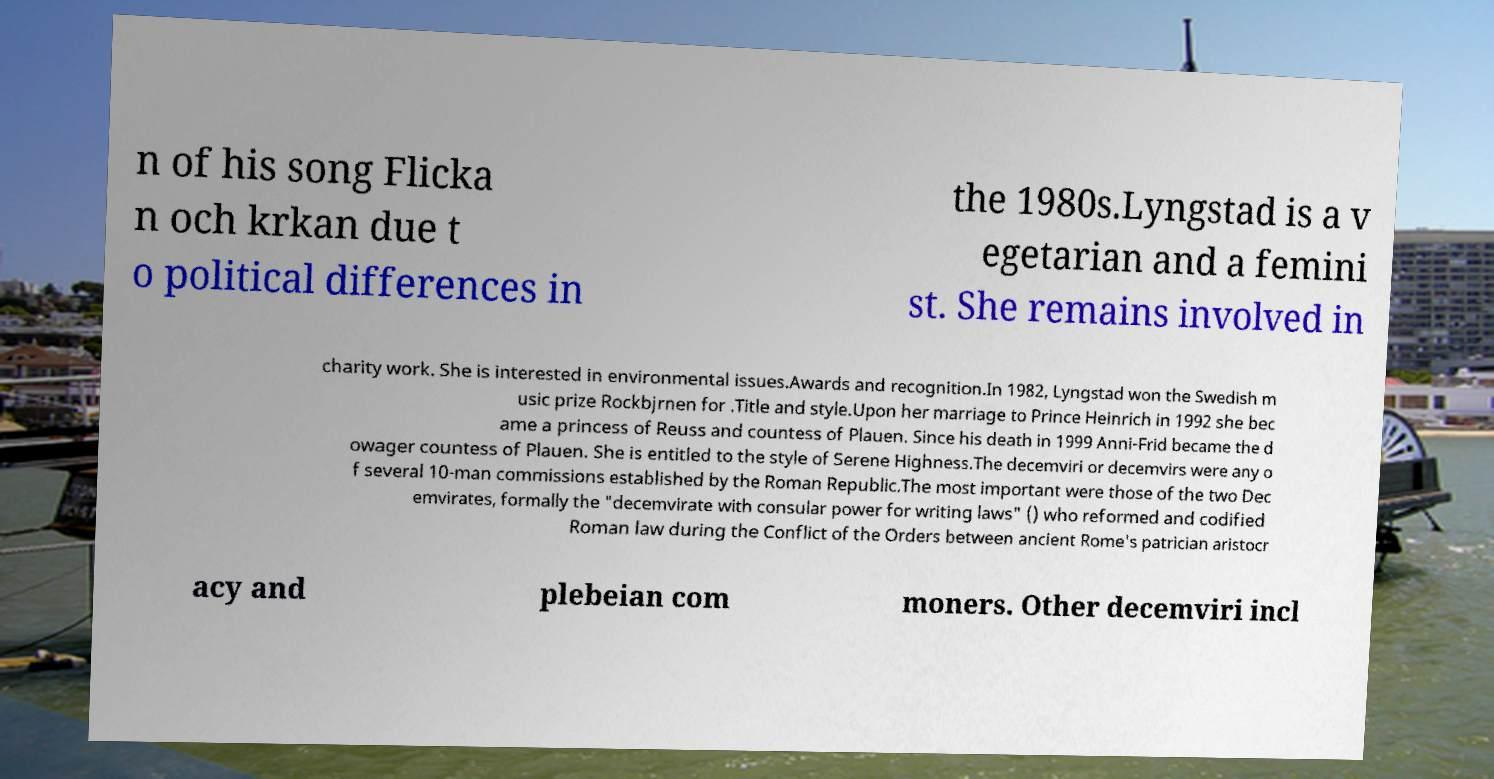Can you read and provide the text displayed in the image?This photo seems to have some interesting text. Can you extract and type it out for me? n of his song Flicka n och krkan due t o political differences in the 1980s.Lyngstad is a v egetarian and a femini st. She remains involved in charity work. She is interested in environmental issues.Awards and recognition.In 1982, Lyngstad won the Swedish m usic prize Rockbjrnen for .Title and style.Upon her marriage to Prince Heinrich in 1992 she bec ame a princess of Reuss and countess of Plauen. Since his death in 1999 Anni-Frid became the d owager countess of Plauen. She is entitled to the style of Serene Highness.The decemviri or decemvirs were any o f several 10-man commissions established by the Roman Republic.The most important were those of the two Dec emvirates, formally the "decemvirate with consular power for writing laws" () who reformed and codified Roman law during the Conflict of the Orders between ancient Rome's patrician aristocr acy and plebeian com moners. Other decemviri incl 